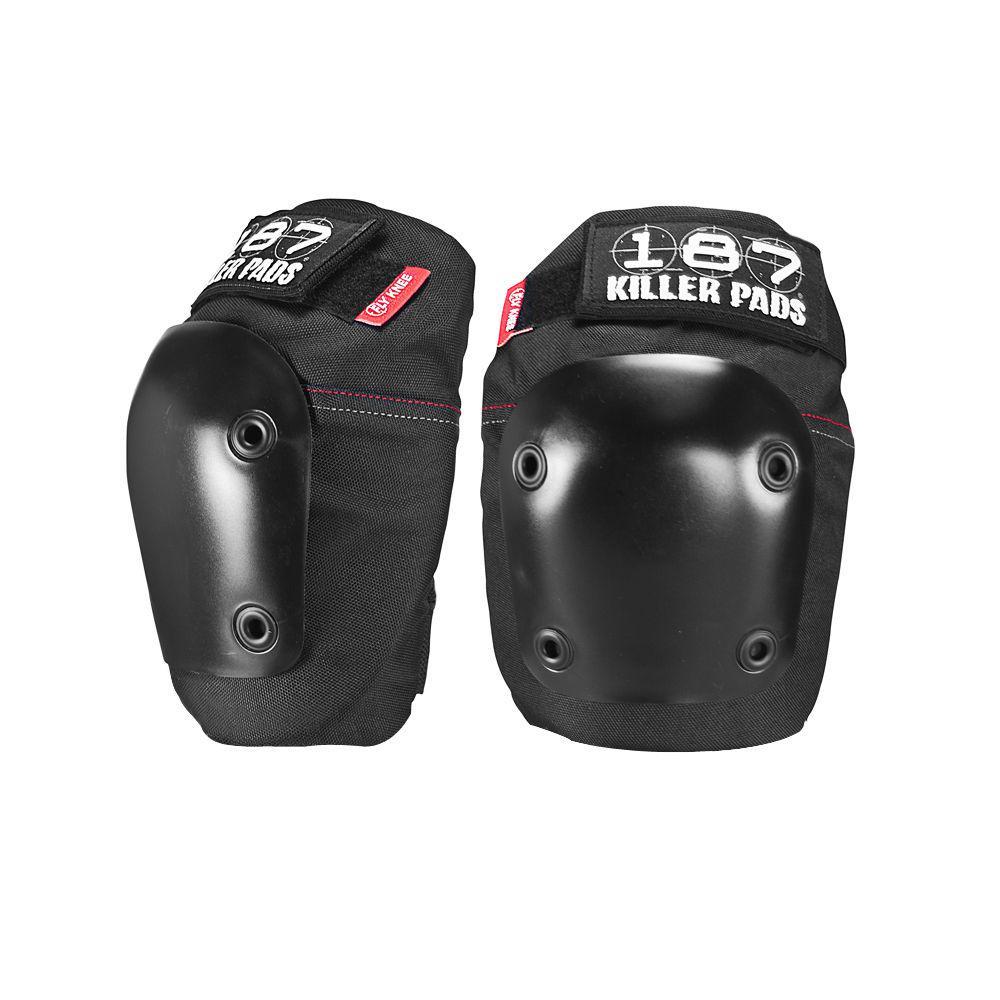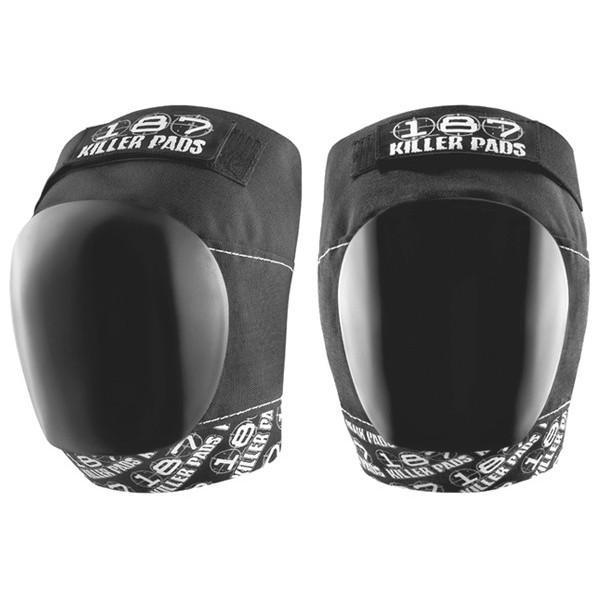The first image is the image on the left, the second image is the image on the right. Considering the images on both sides, is "Each image contains a pair of black knee pads, and one image features a pair of knee pads with black and white print on the tops and bottoms." valid? Answer yes or no. Yes. The first image is the image on the left, the second image is the image on the right. Considering the images on both sides, is "One pair of pads has visible red tags, and the other pair does not." valid? Answer yes or no. Yes. 